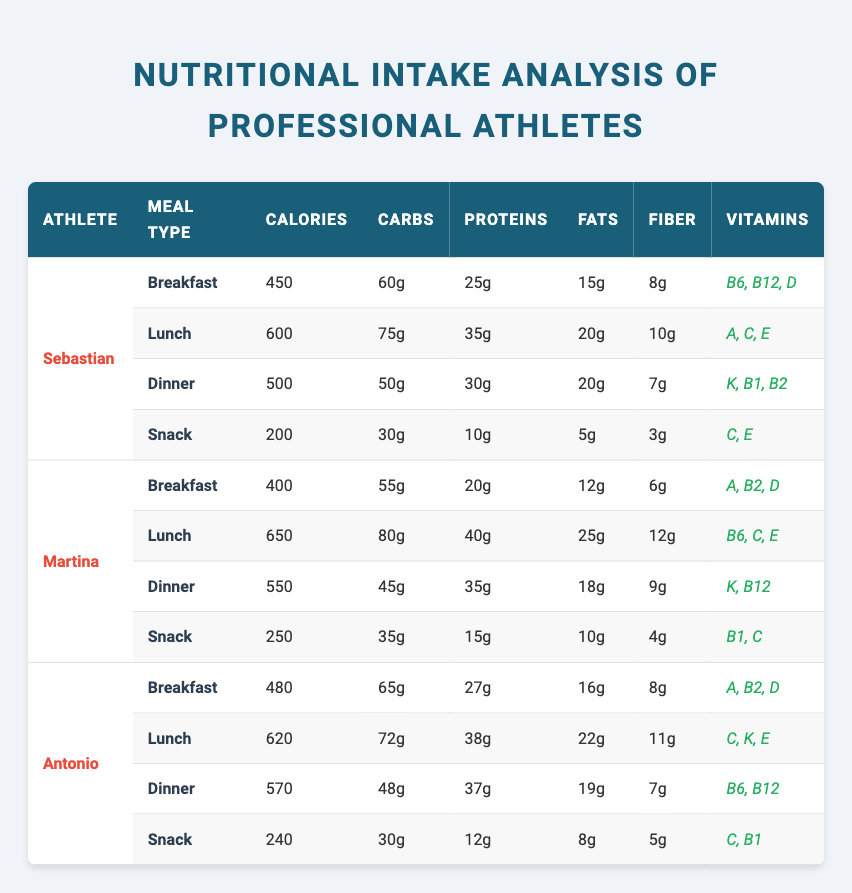What is the total calorie intake of Sebastian for the day? To calculate Sebastian's total calorie intake, add the calories from each of his meals: Breakfast (450) + Lunch (600) + Dinner (500) + Snack (200) = 450 + 600 + 500 + 200 = 1850
Answer: 1850 Which athlete has the highest protein intake at lunch? Looking at the lunch meals of all athletes, Sebastian has 35g, Martina has 40g, Antonio has 38g. The highest is Martina with 40g of protein
Answer: Martina How many grams of carbohydrates does Antonio consume for dinner? The table shows that Antonio has 48g of carbohydrates for his dinner meal
Answer: 48g True or false: Every athlete consumes more carbohydrates at lunch than at breakfast. Checking the values: Sebastian has 75g (lunch) and 60g (breakfast), Martina has 80g (lunch) and 55g (breakfast), Antonio has 72g (lunch) and 65g (breakfast). All are true, so the statement is true
Answer: True What is the average calorie content of Martina's meals? Martina has four meals: Breakfast (400), Lunch (650), Dinner (550), Snack (250). Total calorie count is 400 + 650 + 550 + 250 = 1850. Divide by the number of meals (4): 1850 / 4 = 462.5
Answer: 462.5 Which meal type provides the least amount of fiber across all athletes? By comparing the fiber values: Breakfast (8, 6, 8), Lunch (10, 12, 11), Dinner (7, 9, 7), Snack (3, 4, 5). The Snack meal type has the least fiber with 3g (Sebastian)
Answer: Snack How does the total fat intake at dinner for all athletes compare? The fats for each athlete’s dinner: Sebastian has 20g, Martina has 18g, Antonio has 19g. Adding these gives: 20 + 18 + 19 = 57g. Thus the total fat intake for dinner is 57g
Answer: 57g Who has the highest total fiber intake throughout the day? Calculate the total fiber for each athlete: Sebastian (8 + 10 + 7 + 3 = 28g), Martina (6 + 12 + 9 + 4 = 31g), Antonio (8 + 11 + 7 + 5 = 31g). Martina ties with Antonio for the highest with 31g
Answer: Martina and Antonio Is there any meal type in which all athletes have the same vitamin? By checking vitamin content: Breakfast (D), Lunch (No same vitamin), Dinner (B12, K), Snack (No same vitamin). There is no meal type with the same vitamin across all athletes
Answer: No What percentage of total calories from Antonio’s meals come from lunch? Antonio's total calorie intake is (480 + 620 + 570 + 240) = 1910. The lunch calories are 620. To find the percentage: (620 / 1910) * 100 = 32.4%. So about 32.4% of Antonio's total calorie intake comes from lunch
Answer: 32.4% 